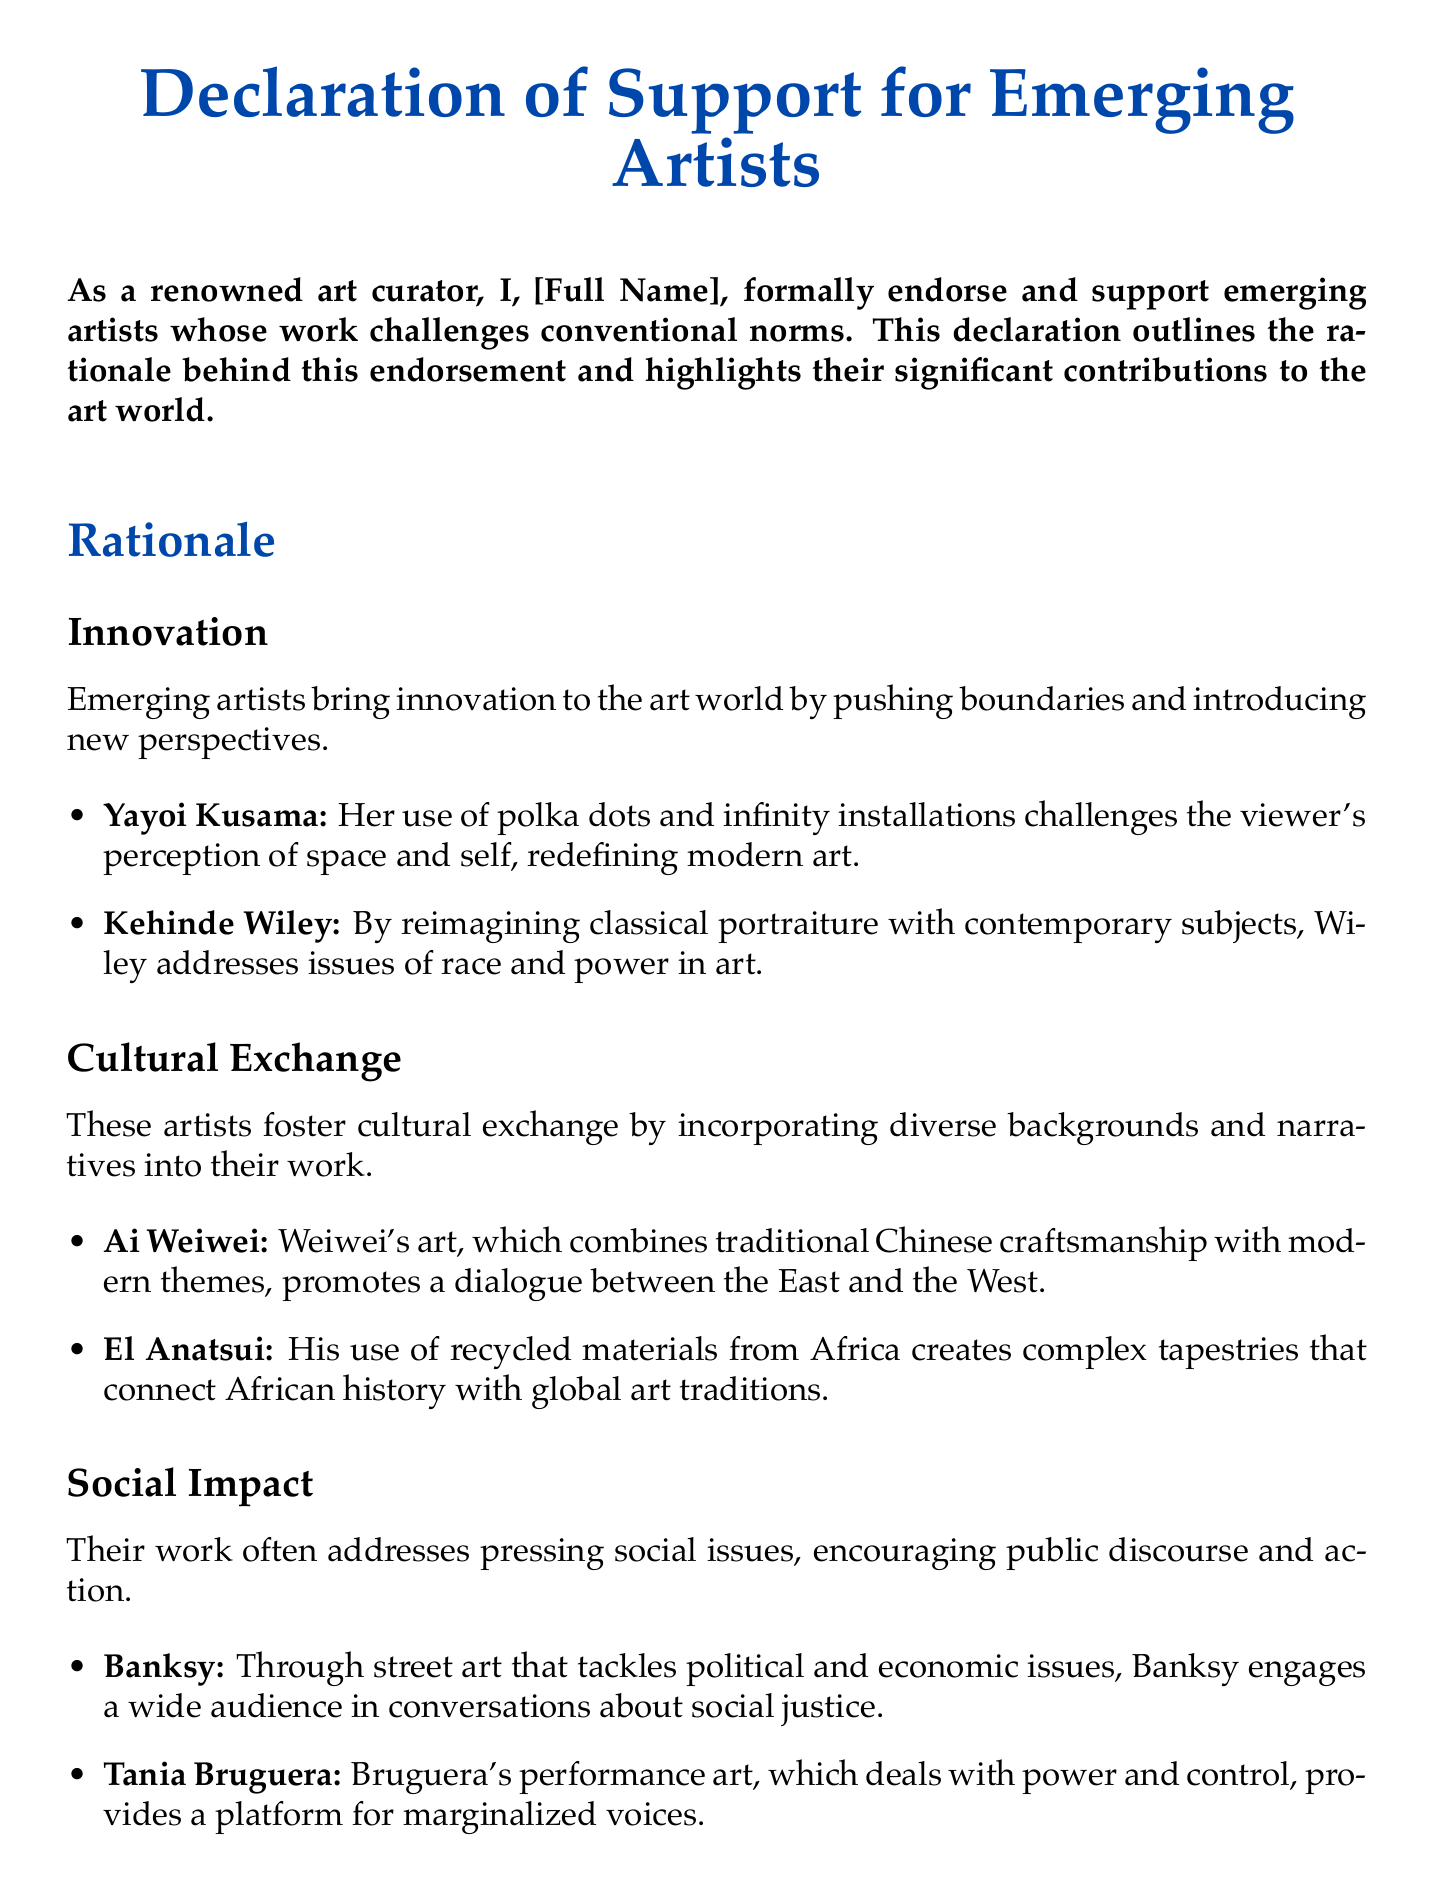What is the title of the document? The title is prominently stated at the beginning of the document, which is "Declaration of Support for Emerging Artists."
Answer: Declaration of Support for Emerging Artists Who endorses emerging artists? The document states the endorsement of emerging artists is made by the signatory, indicated as "[Full Name]."
Answer: [Full Name] What color is used for the title? The title is presented in a specific color, which is defined as art blue.
Answer: art blue Name one artist mentioned in the innovation section. The innovation section includes notable emerging artists, one of whom is Yayoi Kusama.
Answer: Yayoi Kusama What type of art does Banksy create? The document categorizes Banksy's art as "street art."
Answer: street art Which artist focuses on traditional Chinese craftsmanship? According to the cultural exchange section, Ai Weiwei is the artist who incorporates traditional Chinese craftsmanship.
Answer: Ai Weiwei What is the main purpose of this declaration? The primary purpose of the declaration is to support emerging artists whose work challenges conventional norms.
Answer: support emerging artists Which section discusses addressing social issues? The section that directly tackles social issues and encourages public discourse is labeled "Social Impact."
Answer: Social Impact What materials does El Anatsui use in his art? The document highlights that El Anatsui utilizes recycled materials from Africa in his artworks.
Answer: recycled materials from Africa 